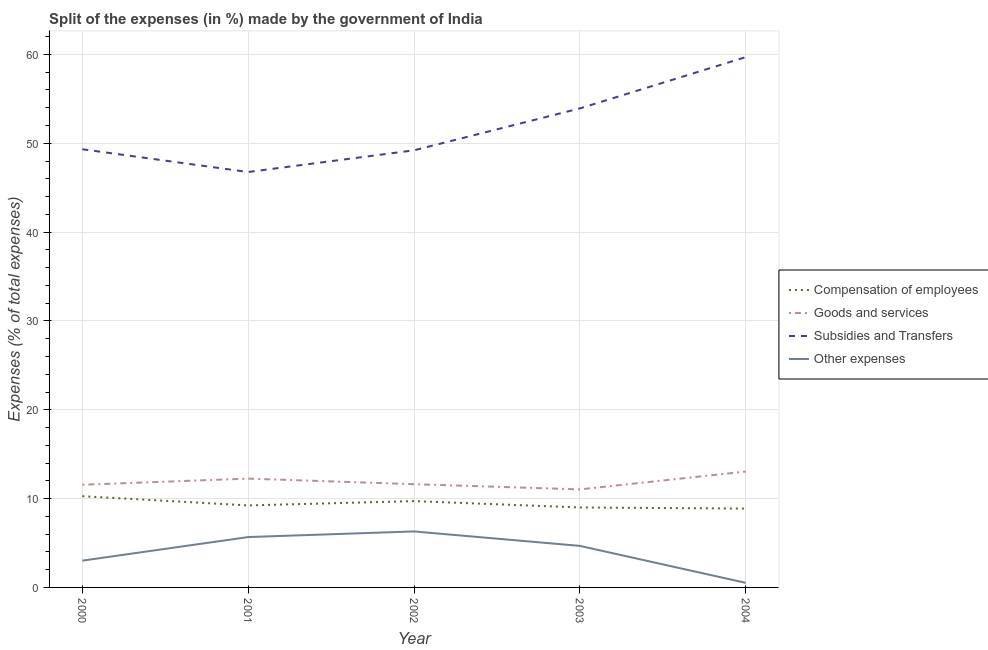How many different coloured lines are there?
Ensure brevity in your answer.  4. Is the number of lines equal to the number of legend labels?
Keep it short and to the point. Yes. What is the percentage of amount spent on subsidies in 2004?
Your answer should be very brief. 59.7. Across all years, what is the maximum percentage of amount spent on other expenses?
Your response must be concise. 6.3. Across all years, what is the minimum percentage of amount spent on other expenses?
Your answer should be compact. 0.52. What is the total percentage of amount spent on goods and services in the graph?
Make the answer very short. 59.51. What is the difference between the percentage of amount spent on other expenses in 2002 and that in 2003?
Ensure brevity in your answer.  1.63. What is the difference between the percentage of amount spent on goods and services in 2000 and the percentage of amount spent on subsidies in 2001?
Make the answer very short. -35.21. What is the average percentage of amount spent on subsidies per year?
Ensure brevity in your answer.  51.79. In the year 2004, what is the difference between the percentage of amount spent on subsidies and percentage of amount spent on goods and services?
Offer a very short reply. 46.66. In how many years, is the percentage of amount spent on subsidies greater than 18 %?
Your response must be concise. 5. What is the ratio of the percentage of amount spent on other expenses in 2000 to that in 2003?
Give a very brief answer. 0.64. What is the difference between the highest and the second highest percentage of amount spent on subsidies?
Offer a terse response. 5.77. What is the difference between the highest and the lowest percentage of amount spent on goods and services?
Ensure brevity in your answer.  2. In how many years, is the percentage of amount spent on subsidies greater than the average percentage of amount spent on subsidies taken over all years?
Your response must be concise. 2. Is the sum of the percentage of amount spent on goods and services in 2003 and 2004 greater than the maximum percentage of amount spent on subsidies across all years?
Ensure brevity in your answer.  No. Is the percentage of amount spent on compensation of employees strictly less than the percentage of amount spent on goods and services over the years?
Offer a very short reply. Yes. How many lines are there?
Make the answer very short. 4. What is the difference between two consecutive major ticks on the Y-axis?
Ensure brevity in your answer.  10. Are the values on the major ticks of Y-axis written in scientific E-notation?
Your response must be concise. No. Does the graph contain any zero values?
Provide a short and direct response. No. Where does the legend appear in the graph?
Your answer should be compact. Center right. How are the legend labels stacked?
Provide a short and direct response. Vertical. What is the title of the graph?
Your answer should be very brief. Split of the expenses (in %) made by the government of India. Does "France" appear as one of the legend labels in the graph?
Keep it short and to the point. No. What is the label or title of the Y-axis?
Provide a succinct answer. Expenses (% of total expenses). What is the Expenses (% of total expenses) in Compensation of employees in 2000?
Give a very brief answer. 10.27. What is the Expenses (% of total expenses) of Goods and services in 2000?
Offer a terse response. 11.56. What is the Expenses (% of total expenses) of Subsidies and Transfers in 2000?
Ensure brevity in your answer.  49.33. What is the Expenses (% of total expenses) of Other expenses in 2000?
Give a very brief answer. 3.02. What is the Expenses (% of total expenses) of Compensation of employees in 2001?
Provide a short and direct response. 9.23. What is the Expenses (% of total expenses) of Goods and services in 2001?
Keep it short and to the point. 12.25. What is the Expenses (% of total expenses) of Subsidies and Transfers in 2001?
Offer a very short reply. 46.77. What is the Expenses (% of total expenses) of Other expenses in 2001?
Offer a very short reply. 5.67. What is the Expenses (% of total expenses) of Compensation of employees in 2002?
Provide a succinct answer. 9.72. What is the Expenses (% of total expenses) of Goods and services in 2002?
Make the answer very short. 11.62. What is the Expenses (% of total expenses) in Subsidies and Transfers in 2002?
Make the answer very short. 49.21. What is the Expenses (% of total expenses) in Other expenses in 2002?
Make the answer very short. 6.3. What is the Expenses (% of total expenses) in Compensation of employees in 2003?
Give a very brief answer. 9. What is the Expenses (% of total expenses) in Goods and services in 2003?
Make the answer very short. 11.04. What is the Expenses (% of total expenses) of Subsidies and Transfers in 2003?
Make the answer very short. 53.93. What is the Expenses (% of total expenses) in Other expenses in 2003?
Give a very brief answer. 4.68. What is the Expenses (% of total expenses) of Compensation of employees in 2004?
Provide a short and direct response. 8.88. What is the Expenses (% of total expenses) in Goods and services in 2004?
Provide a succinct answer. 13.04. What is the Expenses (% of total expenses) of Subsidies and Transfers in 2004?
Give a very brief answer. 59.7. What is the Expenses (% of total expenses) of Other expenses in 2004?
Ensure brevity in your answer.  0.52. Across all years, what is the maximum Expenses (% of total expenses) of Compensation of employees?
Make the answer very short. 10.27. Across all years, what is the maximum Expenses (% of total expenses) in Goods and services?
Your answer should be compact. 13.04. Across all years, what is the maximum Expenses (% of total expenses) in Subsidies and Transfers?
Provide a succinct answer. 59.7. Across all years, what is the maximum Expenses (% of total expenses) of Other expenses?
Ensure brevity in your answer.  6.3. Across all years, what is the minimum Expenses (% of total expenses) of Compensation of employees?
Provide a short and direct response. 8.88. Across all years, what is the minimum Expenses (% of total expenses) of Goods and services?
Your answer should be very brief. 11.04. Across all years, what is the minimum Expenses (% of total expenses) in Subsidies and Transfers?
Offer a very short reply. 46.77. Across all years, what is the minimum Expenses (% of total expenses) of Other expenses?
Provide a succinct answer. 0.52. What is the total Expenses (% of total expenses) in Compensation of employees in the graph?
Give a very brief answer. 47.1. What is the total Expenses (% of total expenses) in Goods and services in the graph?
Provide a succinct answer. 59.51. What is the total Expenses (% of total expenses) of Subsidies and Transfers in the graph?
Keep it short and to the point. 258.94. What is the total Expenses (% of total expenses) of Other expenses in the graph?
Your response must be concise. 20.18. What is the difference between the Expenses (% of total expenses) of Compensation of employees in 2000 and that in 2001?
Provide a short and direct response. 1.04. What is the difference between the Expenses (% of total expenses) in Goods and services in 2000 and that in 2001?
Give a very brief answer. -0.69. What is the difference between the Expenses (% of total expenses) of Subsidies and Transfers in 2000 and that in 2001?
Keep it short and to the point. 2.56. What is the difference between the Expenses (% of total expenses) of Other expenses in 2000 and that in 2001?
Ensure brevity in your answer.  -2.65. What is the difference between the Expenses (% of total expenses) of Compensation of employees in 2000 and that in 2002?
Your answer should be very brief. 0.55. What is the difference between the Expenses (% of total expenses) in Goods and services in 2000 and that in 2002?
Make the answer very short. -0.07. What is the difference between the Expenses (% of total expenses) in Subsidies and Transfers in 2000 and that in 2002?
Make the answer very short. 0.12. What is the difference between the Expenses (% of total expenses) in Other expenses in 2000 and that in 2002?
Make the answer very short. -3.29. What is the difference between the Expenses (% of total expenses) in Compensation of employees in 2000 and that in 2003?
Ensure brevity in your answer.  1.27. What is the difference between the Expenses (% of total expenses) in Goods and services in 2000 and that in 2003?
Your answer should be very brief. 0.52. What is the difference between the Expenses (% of total expenses) of Subsidies and Transfers in 2000 and that in 2003?
Provide a short and direct response. -4.6. What is the difference between the Expenses (% of total expenses) of Other expenses in 2000 and that in 2003?
Give a very brief answer. -1.66. What is the difference between the Expenses (% of total expenses) of Compensation of employees in 2000 and that in 2004?
Your answer should be compact. 1.39. What is the difference between the Expenses (% of total expenses) in Goods and services in 2000 and that in 2004?
Ensure brevity in your answer.  -1.48. What is the difference between the Expenses (% of total expenses) in Subsidies and Transfers in 2000 and that in 2004?
Your answer should be compact. -10.37. What is the difference between the Expenses (% of total expenses) in Other expenses in 2000 and that in 2004?
Offer a very short reply. 2.5. What is the difference between the Expenses (% of total expenses) in Compensation of employees in 2001 and that in 2002?
Provide a succinct answer. -0.48. What is the difference between the Expenses (% of total expenses) of Goods and services in 2001 and that in 2002?
Make the answer very short. 0.63. What is the difference between the Expenses (% of total expenses) of Subsidies and Transfers in 2001 and that in 2002?
Keep it short and to the point. -2.44. What is the difference between the Expenses (% of total expenses) of Other expenses in 2001 and that in 2002?
Your response must be concise. -0.63. What is the difference between the Expenses (% of total expenses) of Compensation of employees in 2001 and that in 2003?
Provide a succinct answer. 0.23. What is the difference between the Expenses (% of total expenses) in Goods and services in 2001 and that in 2003?
Make the answer very short. 1.21. What is the difference between the Expenses (% of total expenses) in Subsidies and Transfers in 2001 and that in 2003?
Your answer should be compact. -7.16. What is the difference between the Expenses (% of total expenses) of Compensation of employees in 2001 and that in 2004?
Your answer should be compact. 0.36. What is the difference between the Expenses (% of total expenses) in Goods and services in 2001 and that in 2004?
Offer a very short reply. -0.79. What is the difference between the Expenses (% of total expenses) of Subsidies and Transfers in 2001 and that in 2004?
Your answer should be very brief. -12.94. What is the difference between the Expenses (% of total expenses) in Other expenses in 2001 and that in 2004?
Keep it short and to the point. 5.15. What is the difference between the Expenses (% of total expenses) in Compensation of employees in 2002 and that in 2003?
Your response must be concise. 0.72. What is the difference between the Expenses (% of total expenses) of Goods and services in 2002 and that in 2003?
Your response must be concise. 0.59. What is the difference between the Expenses (% of total expenses) of Subsidies and Transfers in 2002 and that in 2003?
Make the answer very short. -4.72. What is the difference between the Expenses (% of total expenses) in Other expenses in 2002 and that in 2003?
Ensure brevity in your answer.  1.63. What is the difference between the Expenses (% of total expenses) in Compensation of employees in 2002 and that in 2004?
Keep it short and to the point. 0.84. What is the difference between the Expenses (% of total expenses) in Goods and services in 2002 and that in 2004?
Make the answer very short. -1.42. What is the difference between the Expenses (% of total expenses) in Subsidies and Transfers in 2002 and that in 2004?
Ensure brevity in your answer.  -10.49. What is the difference between the Expenses (% of total expenses) in Other expenses in 2002 and that in 2004?
Give a very brief answer. 5.79. What is the difference between the Expenses (% of total expenses) of Compensation of employees in 2003 and that in 2004?
Offer a very short reply. 0.12. What is the difference between the Expenses (% of total expenses) in Goods and services in 2003 and that in 2004?
Offer a very short reply. -2. What is the difference between the Expenses (% of total expenses) of Subsidies and Transfers in 2003 and that in 2004?
Give a very brief answer. -5.77. What is the difference between the Expenses (% of total expenses) of Other expenses in 2003 and that in 2004?
Give a very brief answer. 4.16. What is the difference between the Expenses (% of total expenses) in Compensation of employees in 2000 and the Expenses (% of total expenses) in Goods and services in 2001?
Your answer should be very brief. -1.98. What is the difference between the Expenses (% of total expenses) in Compensation of employees in 2000 and the Expenses (% of total expenses) in Subsidies and Transfers in 2001?
Your answer should be very brief. -36.5. What is the difference between the Expenses (% of total expenses) of Compensation of employees in 2000 and the Expenses (% of total expenses) of Other expenses in 2001?
Provide a short and direct response. 4.6. What is the difference between the Expenses (% of total expenses) of Goods and services in 2000 and the Expenses (% of total expenses) of Subsidies and Transfers in 2001?
Offer a very short reply. -35.21. What is the difference between the Expenses (% of total expenses) of Goods and services in 2000 and the Expenses (% of total expenses) of Other expenses in 2001?
Provide a short and direct response. 5.89. What is the difference between the Expenses (% of total expenses) in Subsidies and Transfers in 2000 and the Expenses (% of total expenses) in Other expenses in 2001?
Ensure brevity in your answer.  43.66. What is the difference between the Expenses (% of total expenses) of Compensation of employees in 2000 and the Expenses (% of total expenses) of Goods and services in 2002?
Keep it short and to the point. -1.35. What is the difference between the Expenses (% of total expenses) in Compensation of employees in 2000 and the Expenses (% of total expenses) in Subsidies and Transfers in 2002?
Make the answer very short. -38.94. What is the difference between the Expenses (% of total expenses) of Compensation of employees in 2000 and the Expenses (% of total expenses) of Other expenses in 2002?
Give a very brief answer. 3.96. What is the difference between the Expenses (% of total expenses) in Goods and services in 2000 and the Expenses (% of total expenses) in Subsidies and Transfers in 2002?
Offer a very short reply. -37.65. What is the difference between the Expenses (% of total expenses) in Goods and services in 2000 and the Expenses (% of total expenses) in Other expenses in 2002?
Give a very brief answer. 5.25. What is the difference between the Expenses (% of total expenses) in Subsidies and Transfers in 2000 and the Expenses (% of total expenses) in Other expenses in 2002?
Ensure brevity in your answer.  43.03. What is the difference between the Expenses (% of total expenses) in Compensation of employees in 2000 and the Expenses (% of total expenses) in Goods and services in 2003?
Offer a terse response. -0.77. What is the difference between the Expenses (% of total expenses) in Compensation of employees in 2000 and the Expenses (% of total expenses) in Subsidies and Transfers in 2003?
Make the answer very short. -43.66. What is the difference between the Expenses (% of total expenses) in Compensation of employees in 2000 and the Expenses (% of total expenses) in Other expenses in 2003?
Give a very brief answer. 5.59. What is the difference between the Expenses (% of total expenses) of Goods and services in 2000 and the Expenses (% of total expenses) of Subsidies and Transfers in 2003?
Your response must be concise. -42.37. What is the difference between the Expenses (% of total expenses) in Goods and services in 2000 and the Expenses (% of total expenses) in Other expenses in 2003?
Provide a succinct answer. 6.88. What is the difference between the Expenses (% of total expenses) in Subsidies and Transfers in 2000 and the Expenses (% of total expenses) in Other expenses in 2003?
Give a very brief answer. 44.65. What is the difference between the Expenses (% of total expenses) of Compensation of employees in 2000 and the Expenses (% of total expenses) of Goods and services in 2004?
Offer a very short reply. -2.77. What is the difference between the Expenses (% of total expenses) in Compensation of employees in 2000 and the Expenses (% of total expenses) in Subsidies and Transfers in 2004?
Make the answer very short. -49.43. What is the difference between the Expenses (% of total expenses) of Compensation of employees in 2000 and the Expenses (% of total expenses) of Other expenses in 2004?
Give a very brief answer. 9.75. What is the difference between the Expenses (% of total expenses) in Goods and services in 2000 and the Expenses (% of total expenses) in Subsidies and Transfers in 2004?
Your answer should be compact. -48.14. What is the difference between the Expenses (% of total expenses) in Goods and services in 2000 and the Expenses (% of total expenses) in Other expenses in 2004?
Keep it short and to the point. 11.04. What is the difference between the Expenses (% of total expenses) in Subsidies and Transfers in 2000 and the Expenses (% of total expenses) in Other expenses in 2004?
Provide a short and direct response. 48.81. What is the difference between the Expenses (% of total expenses) in Compensation of employees in 2001 and the Expenses (% of total expenses) in Goods and services in 2002?
Offer a terse response. -2.39. What is the difference between the Expenses (% of total expenses) of Compensation of employees in 2001 and the Expenses (% of total expenses) of Subsidies and Transfers in 2002?
Your answer should be very brief. -39.98. What is the difference between the Expenses (% of total expenses) in Compensation of employees in 2001 and the Expenses (% of total expenses) in Other expenses in 2002?
Your response must be concise. 2.93. What is the difference between the Expenses (% of total expenses) of Goods and services in 2001 and the Expenses (% of total expenses) of Subsidies and Transfers in 2002?
Ensure brevity in your answer.  -36.96. What is the difference between the Expenses (% of total expenses) of Goods and services in 2001 and the Expenses (% of total expenses) of Other expenses in 2002?
Your answer should be compact. 5.95. What is the difference between the Expenses (% of total expenses) of Subsidies and Transfers in 2001 and the Expenses (% of total expenses) of Other expenses in 2002?
Keep it short and to the point. 40.46. What is the difference between the Expenses (% of total expenses) of Compensation of employees in 2001 and the Expenses (% of total expenses) of Goods and services in 2003?
Offer a terse response. -1.8. What is the difference between the Expenses (% of total expenses) of Compensation of employees in 2001 and the Expenses (% of total expenses) of Subsidies and Transfers in 2003?
Offer a terse response. -44.7. What is the difference between the Expenses (% of total expenses) of Compensation of employees in 2001 and the Expenses (% of total expenses) of Other expenses in 2003?
Give a very brief answer. 4.56. What is the difference between the Expenses (% of total expenses) in Goods and services in 2001 and the Expenses (% of total expenses) in Subsidies and Transfers in 2003?
Give a very brief answer. -41.68. What is the difference between the Expenses (% of total expenses) in Goods and services in 2001 and the Expenses (% of total expenses) in Other expenses in 2003?
Make the answer very short. 7.58. What is the difference between the Expenses (% of total expenses) in Subsidies and Transfers in 2001 and the Expenses (% of total expenses) in Other expenses in 2003?
Offer a terse response. 42.09. What is the difference between the Expenses (% of total expenses) of Compensation of employees in 2001 and the Expenses (% of total expenses) of Goods and services in 2004?
Offer a terse response. -3.81. What is the difference between the Expenses (% of total expenses) of Compensation of employees in 2001 and the Expenses (% of total expenses) of Subsidies and Transfers in 2004?
Provide a succinct answer. -50.47. What is the difference between the Expenses (% of total expenses) in Compensation of employees in 2001 and the Expenses (% of total expenses) in Other expenses in 2004?
Your response must be concise. 8.72. What is the difference between the Expenses (% of total expenses) in Goods and services in 2001 and the Expenses (% of total expenses) in Subsidies and Transfers in 2004?
Ensure brevity in your answer.  -47.45. What is the difference between the Expenses (% of total expenses) of Goods and services in 2001 and the Expenses (% of total expenses) of Other expenses in 2004?
Provide a succinct answer. 11.74. What is the difference between the Expenses (% of total expenses) in Subsidies and Transfers in 2001 and the Expenses (% of total expenses) in Other expenses in 2004?
Make the answer very short. 46.25. What is the difference between the Expenses (% of total expenses) in Compensation of employees in 2002 and the Expenses (% of total expenses) in Goods and services in 2003?
Ensure brevity in your answer.  -1.32. What is the difference between the Expenses (% of total expenses) of Compensation of employees in 2002 and the Expenses (% of total expenses) of Subsidies and Transfers in 2003?
Keep it short and to the point. -44.21. What is the difference between the Expenses (% of total expenses) of Compensation of employees in 2002 and the Expenses (% of total expenses) of Other expenses in 2003?
Offer a very short reply. 5.04. What is the difference between the Expenses (% of total expenses) in Goods and services in 2002 and the Expenses (% of total expenses) in Subsidies and Transfers in 2003?
Your answer should be very brief. -42.31. What is the difference between the Expenses (% of total expenses) of Goods and services in 2002 and the Expenses (% of total expenses) of Other expenses in 2003?
Offer a terse response. 6.95. What is the difference between the Expenses (% of total expenses) of Subsidies and Transfers in 2002 and the Expenses (% of total expenses) of Other expenses in 2003?
Keep it short and to the point. 44.53. What is the difference between the Expenses (% of total expenses) of Compensation of employees in 2002 and the Expenses (% of total expenses) of Goods and services in 2004?
Your answer should be compact. -3.32. What is the difference between the Expenses (% of total expenses) of Compensation of employees in 2002 and the Expenses (% of total expenses) of Subsidies and Transfers in 2004?
Offer a very short reply. -49.99. What is the difference between the Expenses (% of total expenses) in Compensation of employees in 2002 and the Expenses (% of total expenses) in Other expenses in 2004?
Ensure brevity in your answer.  9.2. What is the difference between the Expenses (% of total expenses) of Goods and services in 2002 and the Expenses (% of total expenses) of Subsidies and Transfers in 2004?
Your answer should be compact. -48.08. What is the difference between the Expenses (% of total expenses) of Goods and services in 2002 and the Expenses (% of total expenses) of Other expenses in 2004?
Give a very brief answer. 11.11. What is the difference between the Expenses (% of total expenses) in Subsidies and Transfers in 2002 and the Expenses (% of total expenses) in Other expenses in 2004?
Offer a terse response. 48.69. What is the difference between the Expenses (% of total expenses) of Compensation of employees in 2003 and the Expenses (% of total expenses) of Goods and services in 2004?
Give a very brief answer. -4.04. What is the difference between the Expenses (% of total expenses) in Compensation of employees in 2003 and the Expenses (% of total expenses) in Subsidies and Transfers in 2004?
Make the answer very short. -50.7. What is the difference between the Expenses (% of total expenses) of Compensation of employees in 2003 and the Expenses (% of total expenses) of Other expenses in 2004?
Make the answer very short. 8.49. What is the difference between the Expenses (% of total expenses) in Goods and services in 2003 and the Expenses (% of total expenses) in Subsidies and Transfers in 2004?
Give a very brief answer. -48.67. What is the difference between the Expenses (% of total expenses) of Goods and services in 2003 and the Expenses (% of total expenses) of Other expenses in 2004?
Your answer should be very brief. 10.52. What is the difference between the Expenses (% of total expenses) in Subsidies and Transfers in 2003 and the Expenses (% of total expenses) in Other expenses in 2004?
Your answer should be compact. 53.41. What is the average Expenses (% of total expenses) in Compensation of employees per year?
Offer a terse response. 9.42. What is the average Expenses (% of total expenses) in Goods and services per year?
Your response must be concise. 11.9. What is the average Expenses (% of total expenses) in Subsidies and Transfers per year?
Your answer should be compact. 51.79. What is the average Expenses (% of total expenses) of Other expenses per year?
Make the answer very short. 4.04. In the year 2000, what is the difference between the Expenses (% of total expenses) in Compensation of employees and Expenses (% of total expenses) in Goods and services?
Make the answer very short. -1.29. In the year 2000, what is the difference between the Expenses (% of total expenses) of Compensation of employees and Expenses (% of total expenses) of Subsidies and Transfers?
Ensure brevity in your answer.  -39.06. In the year 2000, what is the difference between the Expenses (% of total expenses) in Compensation of employees and Expenses (% of total expenses) in Other expenses?
Make the answer very short. 7.25. In the year 2000, what is the difference between the Expenses (% of total expenses) in Goods and services and Expenses (% of total expenses) in Subsidies and Transfers?
Offer a terse response. -37.77. In the year 2000, what is the difference between the Expenses (% of total expenses) of Goods and services and Expenses (% of total expenses) of Other expenses?
Your answer should be compact. 8.54. In the year 2000, what is the difference between the Expenses (% of total expenses) in Subsidies and Transfers and Expenses (% of total expenses) in Other expenses?
Ensure brevity in your answer.  46.31. In the year 2001, what is the difference between the Expenses (% of total expenses) of Compensation of employees and Expenses (% of total expenses) of Goods and services?
Offer a terse response. -3.02. In the year 2001, what is the difference between the Expenses (% of total expenses) of Compensation of employees and Expenses (% of total expenses) of Subsidies and Transfers?
Provide a succinct answer. -37.53. In the year 2001, what is the difference between the Expenses (% of total expenses) of Compensation of employees and Expenses (% of total expenses) of Other expenses?
Ensure brevity in your answer.  3.56. In the year 2001, what is the difference between the Expenses (% of total expenses) of Goods and services and Expenses (% of total expenses) of Subsidies and Transfers?
Offer a terse response. -34.52. In the year 2001, what is the difference between the Expenses (% of total expenses) in Goods and services and Expenses (% of total expenses) in Other expenses?
Give a very brief answer. 6.58. In the year 2001, what is the difference between the Expenses (% of total expenses) in Subsidies and Transfers and Expenses (% of total expenses) in Other expenses?
Your answer should be compact. 41.1. In the year 2002, what is the difference between the Expenses (% of total expenses) of Compensation of employees and Expenses (% of total expenses) of Goods and services?
Your answer should be compact. -1.91. In the year 2002, what is the difference between the Expenses (% of total expenses) of Compensation of employees and Expenses (% of total expenses) of Subsidies and Transfers?
Your response must be concise. -39.49. In the year 2002, what is the difference between the Expenses (% of total expenses) in Compensation of employees and Expenses (% of total expenses) in Other expenses?
Your answer should be compact. 3.41. In the year 2002, what is the difference between the Expenses (% of total expenses) of Goods and services and Expenses (% of total expenses) of Subsidies and Transfers?
Your answer should be compact. -37.59. In the year 2002, what is the difference between the Expenses (% of total expenses) of Goods and services and Expenses (% of total expenses) of Other expenses?
Keep it short and to the point. 5.32. In the year 2002, what is the difference between the Expenses (% of total expenses) of Subsidies and Transfers and Expenses (% of total expenses) of Other expenses?
Keep it short and to the point. 42.91. In the year 2003, what is the difference between the Expenses (% of total expenses) in Compensation of employees and Expenses (% of total expenses) in Goods and services?
Give a very brief answer. -2.04. In the year 2003, what is the difference between the Expenses (% of total expenses) in Compensation of employees and Expenses (% of total expenses) in Subsidies and Transfers?
Keep it short and to the point. -44.93. In the year 2003, what is the difference between the Expenses (% of total expenses) of Compensation of employees and Expenses (% of total expenses) of Other expenses?
Your answer should be very brief. 4.33. In the year 2003, what is the difference between the Expenses (% of total expenses) of Goods and services and Expenses (% of total expenses) of Subsidies and Transfers?
Make the answer very short. -42.89. In the year 2003, what is the difference between the Expenses (% of total expenses) of Goods and services and Expenses (% of total expenses) of Other expenses?
Provide a short and direct response. 6.36. In the year 2003, what is the difference between the Expenses (% of total expenses) in Subsidies and Transfers and Expenses (% of total expenses) in Other expenses?
Provide a short and direct response. 49.25. In the year 2004, what is the difference between the Expenses (% of total expenses) in Compensation of employees and Expenses (% of total expenses) in Goods and services?
Provide a succinct answer. -4.17. In the year 2004, what is the difference between the Expenses (% of total expenses) of Compensation of employees and Expenses (% of total expenses) of Subsidies and Transfers?
Give a very brief answer. -50.83. In the year 2004, what is the difference between the Expenses (% of total expenses) of Compensation of employees and Expenses (% of total expenses) of Other expenses?
Make the answer very short. 8.36. In the year 2004, what is the difference between the Expenses (% of total expenses) in Goods and services and Expenses (% of total expenses) in Subsidies and Transfers?
Provide a short and direct response. -46.66. In the year 2004, what is the difference between the Expenses (% of total expenses) of Goods and services and Expenses (% of total expenses) of Other expenses?
Give a very brief answer. 12.53. In the year 2004, what is the difference between the Expenses (% of total expenses) of Subsidies and Transfers and Expenses (% of total expenses) of Other expenses?
Ensure brevity in your answer.  59.19. What is the ratio of the Expenses (% of total expenses) in Compensation of employees in 2000 to that in 2001?
Provide a short and direct response. 1.11. What is the ratio of the Expenses (% of total expenses) of Goods and services in 2000 to that in 2001?
Your answer should be very brief. 0.94. What is the ratio of the Expenses (% of total expenses) in Subsidies and Transfers in 2000 to that in 2001?
Give a very brief answer. 1.05. What is the ratio of the Expenses (% of total expenses) of Other expenses in 2000 to that in 2001?
Give a very brief answer. 0.53. What is the ratio of the Expenses (% of total expenses) in Compensation of employees in 2000 to that in 2002?
Your response must be concise. 1.06. What is the ratio of the Expenses (% of total expenses) of Subsidies and Transfers in 2000 to that in 2002?
Provide a succinct answer. 1. What is the ratio of the Expenses (% of total expenses) of Other expenses in 2000 to that in 2002?
Make the answer very short. 0.48. What is the ratio of the Expenses (% of total expenses) in Compensation of employees in 2000 to that in 2003?
Your answer should be very brief. 1.14. What is the ratio of the Expenses (% of total expenses) in Goods and services in 2000 to that in 2003?
Your answer should be compact. 1.05. What is the ratio of the Expenses (% of total expenses) in Subsidies and Transfers in 2000 to that in 2003?
Provide a succinct answer. 0.91. What is the ratio of the Expenses (% of total expenses) of Other expenses in 2000 to that in 2003?
Keep it short and to the point. 0.64. What is the ratio of the Expenses (% of total expenses) of Compensation of employees in 2000 to that in 2004?
Ensure brevity in your answer.  1.16. What is the ratio of the Expenses (% of total expenses) of Goods and services in 2000 to that in 2004?
Offer a terse response. 0.89. What is the ratio of the Expenses (% of total expenses) of Subsidies and Transfers in 2000 to that in 2004?
Offer a terse response. 0.83. What is the ratio of the Expenses (% of total expenses) of Other expenses in 2000 to that in 2004?
Offer a very short reply. 5.85. What is the ratio of the Expenses (% of total expenses) of Compensation of employees in 2001 to that in 2002?
Provide a succinct answer. 0.95. What is the ratio of the Expenses (% of total expenses) in Goods and services in 2001 to that in 2002?
Your response must be concise. 1.05. What is the ratio of the Expenses (% of total expenses) in Subsidies and Transfers in 2001 to that in 2002?
Keep it short and to the point. 0.95. What is the ratio of the Expenses (% of total expenses) of Other expenses in 2001 to that in 2002?
Your response must be concise. 0.9. What is the ratio of the Expenses (% of total expenses) of Compensation of employees in 2001 to that in 2003?
Provide a short and direct response. 1.03. What is the ratio of the Expenses (% of total expenses) in Goods and services in 2001 to that in 2003?
Ensure brevity in your answer.  1.11. What is the ratio of the Expenses (% of total expenses) in Subsidies and Transfers in 2001 to that in 2003?
Provide a short and direct response. 0.87. What is the ratio of the Expenses (% of total expenses) of Other expenses in 2001 to that in 2003?
Give a very brief answer. 1.21. What is the ratio of the Expenses (% of total expenses) of Compensation of employees in 2001 to that in 2004?
Provide a short and direct response. 1.04. What is the ratio of the Expenses (% of total expenses) of Goods and services in 2001 to that in 2004?
Offer a very short reply. 0.94. What is the ratio of the Expenses (% of total expenses) of Subsidies and Transfers in 2001 to that in 2004?
Make the answer very short. 0.78. What is the ratio of the Expenses (% of total expenses) in Other expenses in 2001 to that in 2004?
Give a very brief answer. 10.99. What is the ratio of the Expenses (% of total expenses) in Compensation of employees in 2002 to that in 2003?
Offer a terse response. 1.08. What is the ratio of the Expenses (% of total expenses) of Goods and services in 2002 to that in 2003?
Offer a terse response. 1.05. What is the ratio of the Expenses (% of total expenses) in Subsidies and Transfers in 2002 to that in 2003?
Ensure brevity in your answer.  0.91. What is the ratio of the Expenses (% of total expenses) in Other expenses in 2002 to that in 2003?
Provide a short and direct response. 1.35. What is the ratio of the Expenses (% of total expenses) in Compensation of employees in 2002 to that in 2004?
Provide a short and direct response. 1.09. What is the ratio of the Expenses (% of total expenses) of Goods and services in 2002 to that in 2004?
Offer a very short reply. 0.89. What is the ratio of the Expenses (% of total expenses) in Subsidies and Transfers in 2002 to that in 2004?
Make the answer very short. 0.82. What is the ratio of the Expenses (% of total expenses) in Other expenses in 2002 to that in 2004?
Provide a short and direct response. 12.22. What is the ratio of the Expenses (% of total expenses) in Compensation of employees in 2003 to that in 2004?
Offer a very short reply. 1.01. What is the ratio of the Expenses (% of total expenses) of Goods and services in 2003 to that in 2004?
Your answer should be very brief. 0.85. What is the ratio of the Expenses (% of total expenses) of Subsidies and Transfers in 2003 to that in 2004?
Provide a short and direct response. 0.9. What is the ratio of the Expenses (% of total expenses) of Other expenses in 2003 to that in 2004?
Ensure brevity in your answer.  9.07. What is the difference between the highest and the second highest Expenses (% of total expenses) of Compensation of employees?
Your answer should be compact. 0.55. What is the difference between the highest and the second highest Expenses (% of total expenses) of Goods and services?
Provide a succinct answer. 0.79. What is the difference between the highest and the second highest Expenses (% of total expenses) in Subsidies and Transfers?
Your response must be concise. 5.77. What is the difference between the highest and the second highest Expenses (% of total expenses) of Other expenses?
Make the answer very short. 0.63. What is the difference between the highest and the lowest Expenses (% of total expenses) of Compensation of employees?
Your answer should be compact. 1.39. What is the difference between the highest and the lowest Expenses (% of total expenses) of Goods and services?
Provide a short and direct response. 2. What is the difference between the highest and the lowest Expenses (% of total expenses) in Subsidies and Transfers?
Your response must be concise. 12.94. What is the difference between the highest and the lowest Expenses (% of total expenses) in Other expenses?
Offer a terse response. 5.79. 